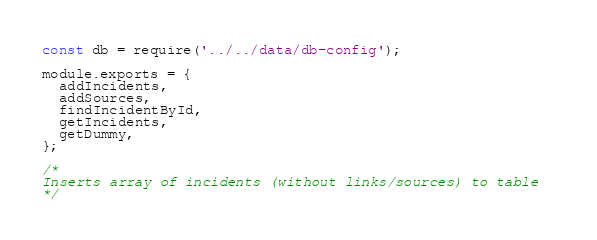<code> <loc_0><loc_0><loc_500><loc_500><_JavaScript_>const db = require('../../data/db-config');

module.exports = {
  addIncidents,
  addSources,
  findIncidentById,
  getIncidents,
  getDummy,
};

/* 
Inserts array of incidents (without links/sources) to table  
*/</code> 